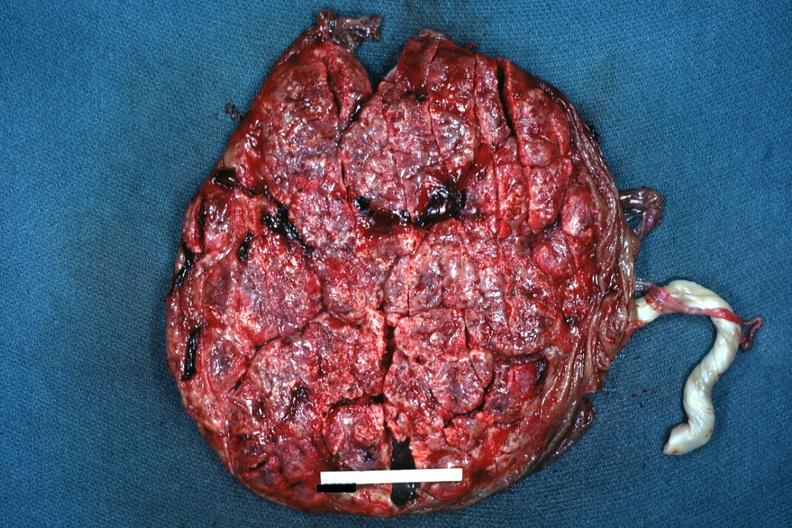does this image show seen from fetal surface term placenta?
Answer the question using a single word or phrase. Yes 